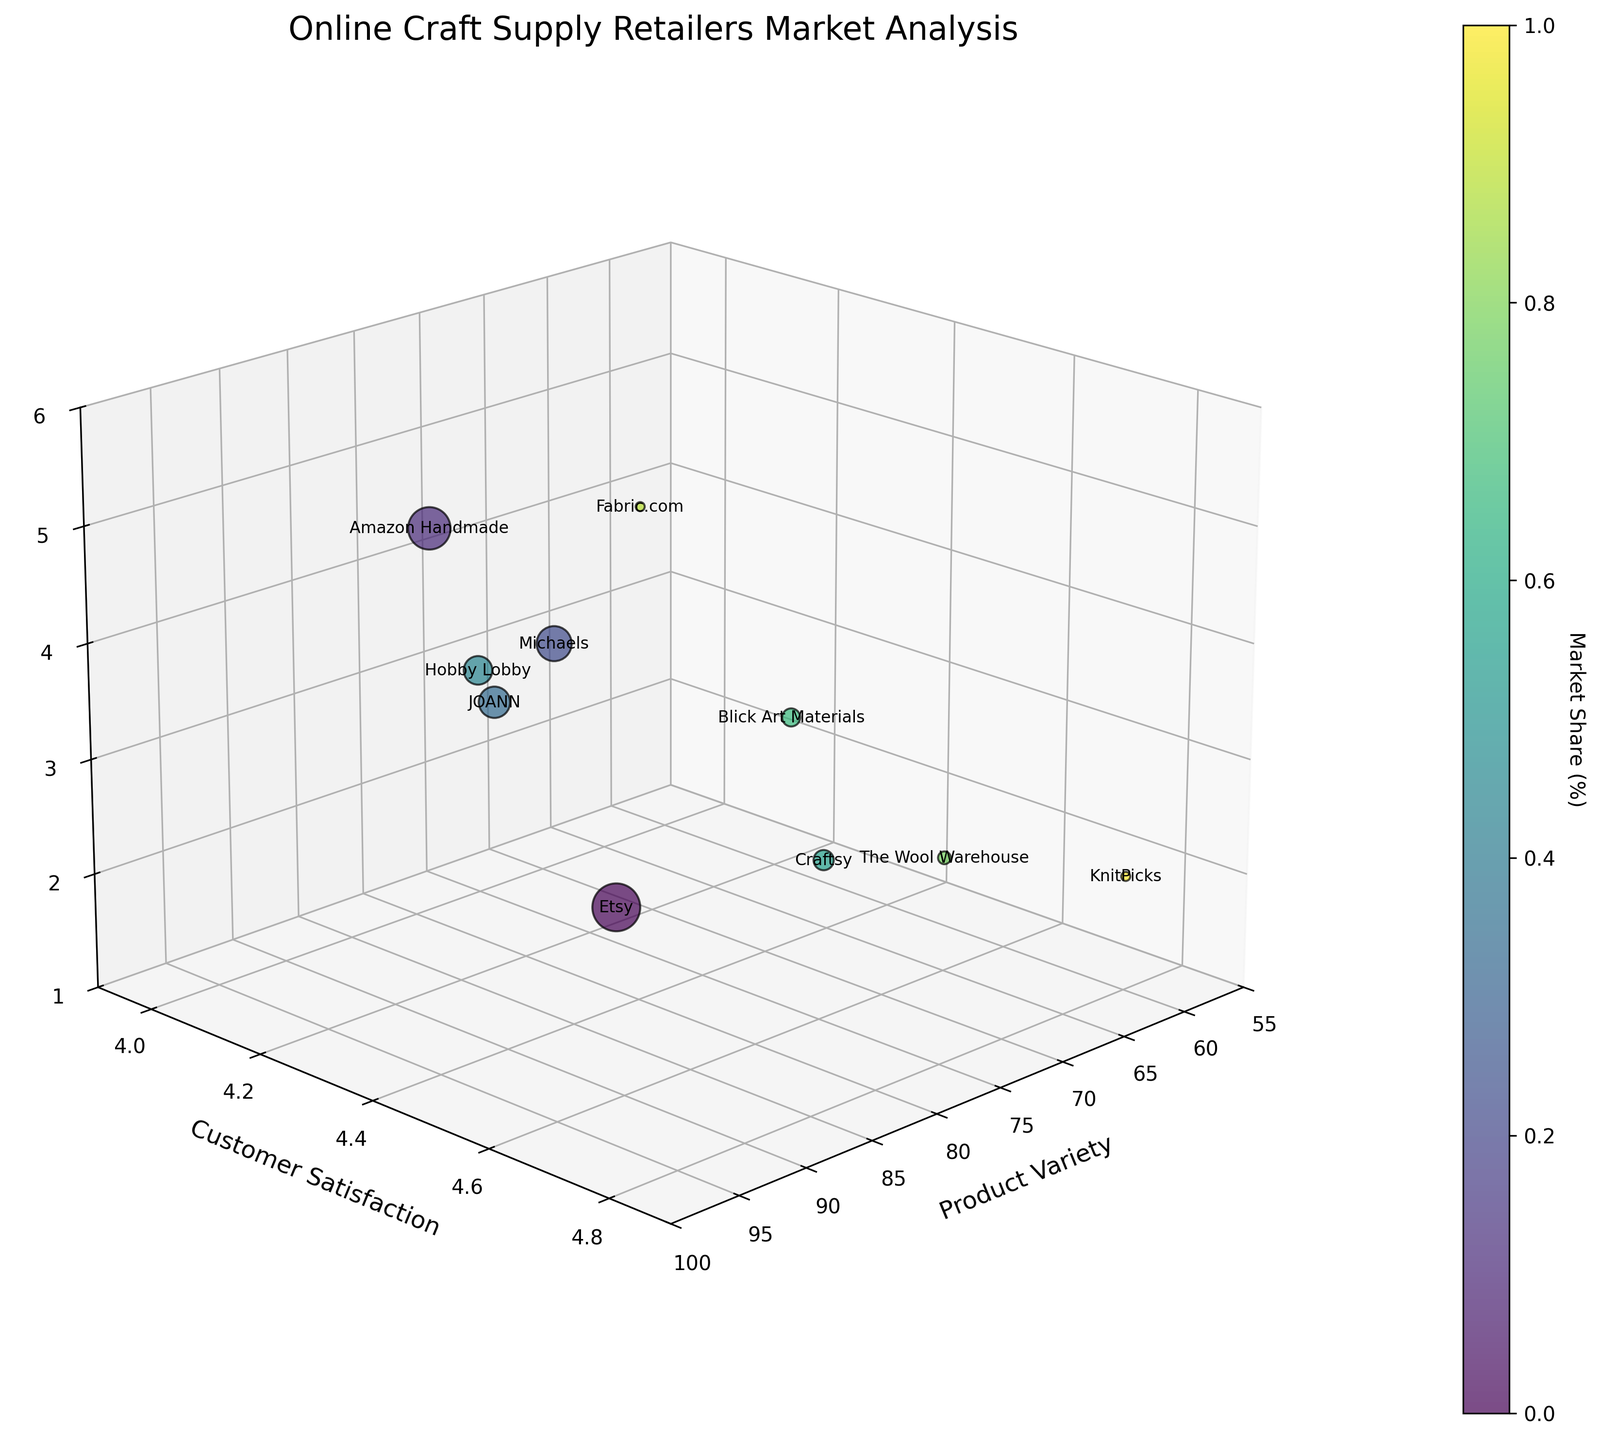What is the title of the figure? The title of the figure is typically found at the top of the chart, above the plotting area. In this case, it is "Online Craft Supply Retailers Market Analysis," which is clearly labeled above the 3D bubble chart.
Answer: Online Craft Supply Retailers Market Analysis Which retailer has the highest customer satisfaction? To determine the retailer with the highest customer satisfaction, look for the data point with the highest y-value on the Customer Satisfaction axis. In this case, KnitPicks has the highest customer satisfaction with a score of 4.8.
Answer: KnitPicks How many retailers have a shipping speed of 3? To find the number of retailers with a shipping speed of 3, count the number of data points where the z-value on the Shipping Speed axis is 3. From the plotted points, we see that Etsy, JOANN, Hobby Lobby, and Blick Art Materials have a shipping speed of 3.
Answer: 4 Comparing Etsy and Amazon Handmade, which has a larger market share? Market share is depicted by the bubble size. Larger bubbles represent a higher market share. By comparing the sizes of the bubbles for Etsy and Amazon Handmade, Etsy’s bubble is larger.
Answer: Etsy What is the average customer satisfaction among Etsy, Amazon Handmade, and Michaels? To calculate the average customer satisfaction, add the satisfaction scores of Etsy (4.7), Amazon Handmade (4.2), and Michaels (4.3), and divide by the number of retailers: (4.7 + 4.2 + 4.3) / 3 = 4.4.
Answer: 4.4 Which retailer has the lowest product variety and what is its market share? Find the data point with the lowest x-value on the Product Variety axis. KnitPicks has the lowest product variety score of 60 and has a market share of 1%.
Answer: KnitPicks, 1% How does customer satisfaction correlate with shipping speed in the chart? Observe the general trend between the y-axis (Customer Satisfaction) and the z-axis (Shipping Speed). Higher customer satisfaction (such as KnitPicks and The Wool Warehouse) tends to be associated with slower shipping speeds (lower z-values). Conversely, retailers with faster shipping speeds like Amazon Handmade have slightly lower customer satisfaction.
Answer: Higher satisfaction often correlates with slower shipping What is the total market share for all retailers? To find the total market share, sum the market shares of all retailers: 28 + 22 + 15 + 12 + 10 + 5 + 4 + 2 + 1 + 1 = 100.
Answer: 100 Which retailer is closest to the middle point for product variety (around 75) and customer satisfaction (around 4.3)? To find the retailer closest to these midpoints, look for a data point near the x-value of 75 and y-value of 4.3. Hobby Lobby is closest with a product variety of 75 and customer satisfaction of 4.0.
Answer: Hobby Lobby What color corresponds to Blick Art Materials, and how does its market share compare with The Wool Warehouse? The color associated with Blick Art Materials can be identified from the color gradient bar. Then compare the sizes of the bubbles for market share. Blick Art Materials has a market share of 4%, and The Wool Warehouse has a market share of 2%. Blick Art Materials' bubble is larger.
Answer: Blick Art Materials is twice as large as The Wool Warehouse 